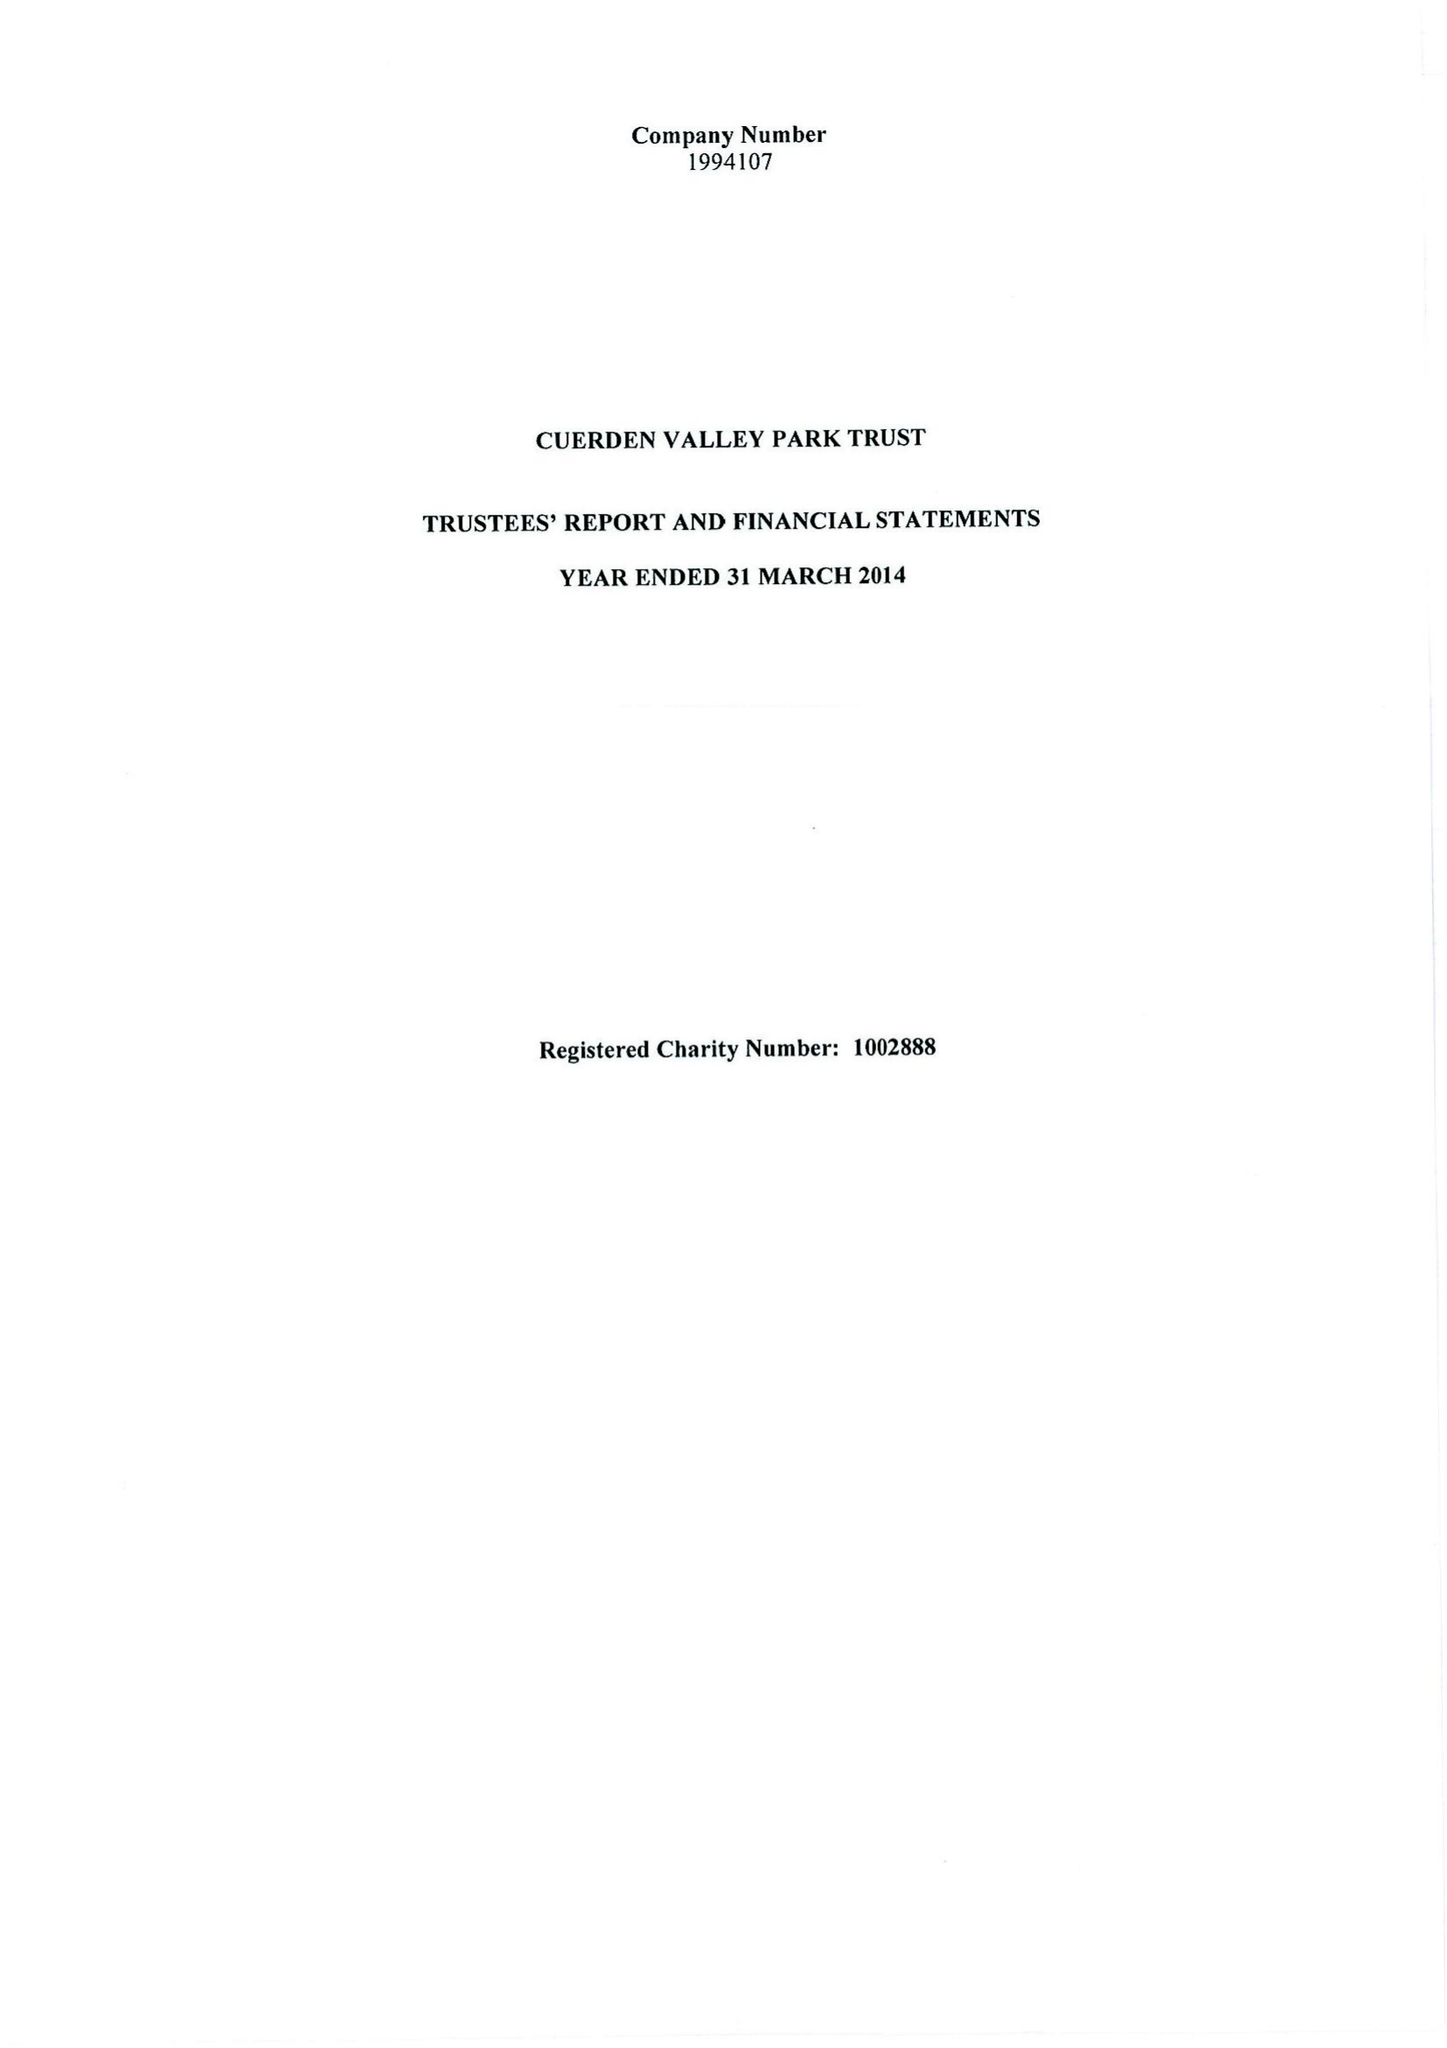What is the value for the charity_number?
Answer the question using a single word or phrase. 1002888 